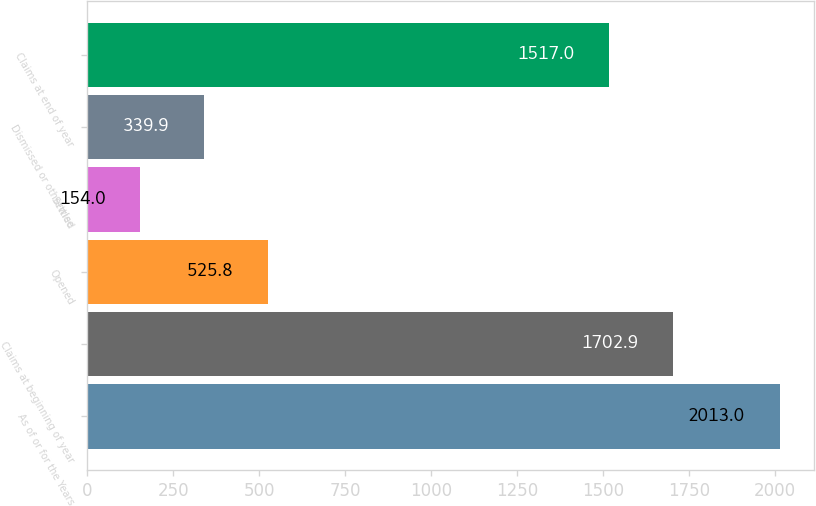Convert chart to OTSL. <chart><loc_0><loc_0><loc_500><loc_500><bar_chart><fcel>As of or for the Years<fcel>Claims at beginning of year<fcel>Opened<fcel>Settled<fcel>Dismissed or otherwise<fcel>Claims at end of year<nl><fcel>2013<fcel>1702.9<fcel>525.8<fcel>154<fcel>339.9<fcel>1517<nl></chart> 